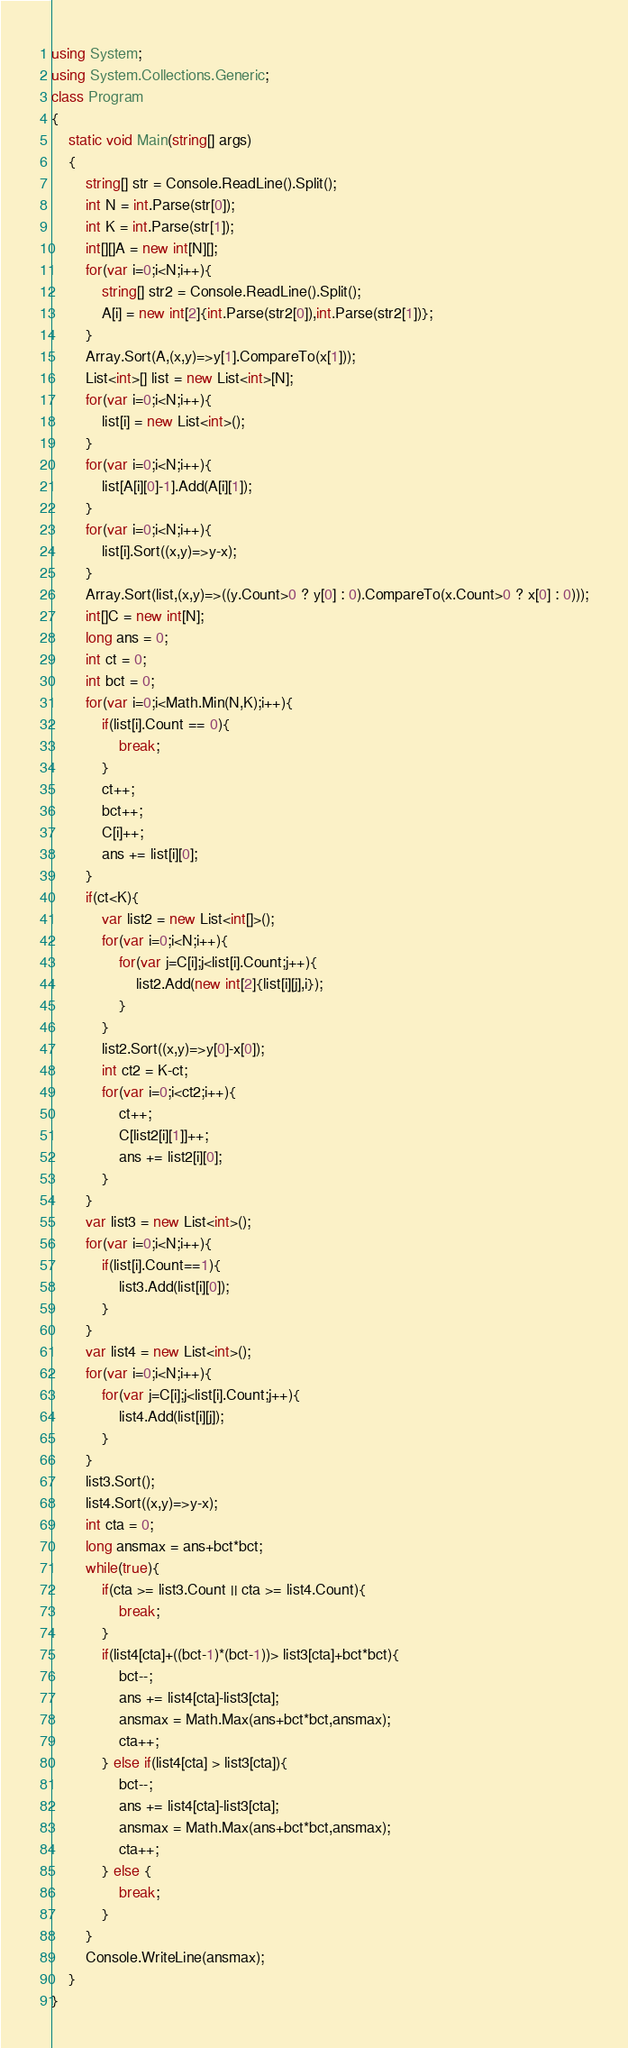<code> <loc_0><loc_0><loc_500><loc_500><_C#_>using System;
using System.Collections.Generic;
class Program
{
	static void Main(string[] args)
	{
		string[] str = Console.ReadLine().Split();
		int N = int.Parse(str[0]);
		int K = int.Parse(str[1]);
		int[][]A = new int[N][];
		for(var i=0;i<N;i++){
			string[] str2 = Console.ReadLine().Split();
			A[i] = new int[2]{int.Parse(str2[0]),int.Parse(str2[1])};
		}
		Array.Sort(A,(x,y)=>y[1].CompareTo(x[1]));
		List<int>[] list = new List<int>[N];
		for(var i=0;i<N;i++){
			list[i] = new List<int>();
		}
		for(var i=0;i<N;i++){
			list[A[i][0]-1].Add(A[i][1]);
		}
		for(var i=0;i<N;i++){
			list[i].Sort((x,y)=>y-x);
		}
		Array.Sort(list,(x,y)=>((y.Count>0 ? y[0] : 0).CompareTo(x.Count>0 ? x[0] : 0)));
		int[]C = new int[N];
		long ans = 0;
		int ct = 0;
		int bct = 0;
		for(var i=0;i<Math.Min(N,K);i++){
			if(list[i].Count == 0){
				break;
			}
			ct++;
			bct++;
			C[i]++;
			ans += list[i][0];
		}
		if(ct<K){
			var list2 = new List<int[]>();
			for(var i=0;i<N;i++){
				for(var j=C[i];j<list[i].Count;j++){
					list2.Add(new int[2]{list[i][j],i});
				}
			}
			list2.Sort((x,y)=>y[0]-x[0]);
			int ct2 = K-ct;
			for(var i=0;i<ct2;i++){
				ct++;
				C[list2[i][1]]++;
				ans += list2[i][0];
			}
		}
		var list3 = new List<int>();
		for(var i=0;i<N;i++){
			if(list[i].Count==1){
				list3.Add(list[i][0]);
			}
		}
		var list4 = new List<int>();
		for(var i=0;i<N;i++){
			for(var j=C[i];j<list[i].Count;j++){
				list4.Add(list[i][j]);
			}
		}
		list3.Sort();
		list4.Sort((x,y)=>y-x);
		int cta = 0;
		long ansmax = ans+bct*bct;
		while(true){
			if(cta >= list3.Count || cta >= list4.Count){
				break;
			}
			if(list4[cta]+((bct-1)*(bct-1))> list3[cta]+bct*bct){
				bct--;
				ans += list4[cta]-list3[cta];
				ansmax = Math.Max(ans+bct*bct,ansmax);
				cta++;
			} else if(list4[cta] > list3[cta]){
				bct--;
				ans += list4[cta]-list3[cta];
				ansmax = Math.Max(ans+bct*bct,ansmax);
				cta++;
			} else {
				break;
			}
		}
		Console.WriteLine(ansmax);
	}
}</code> 